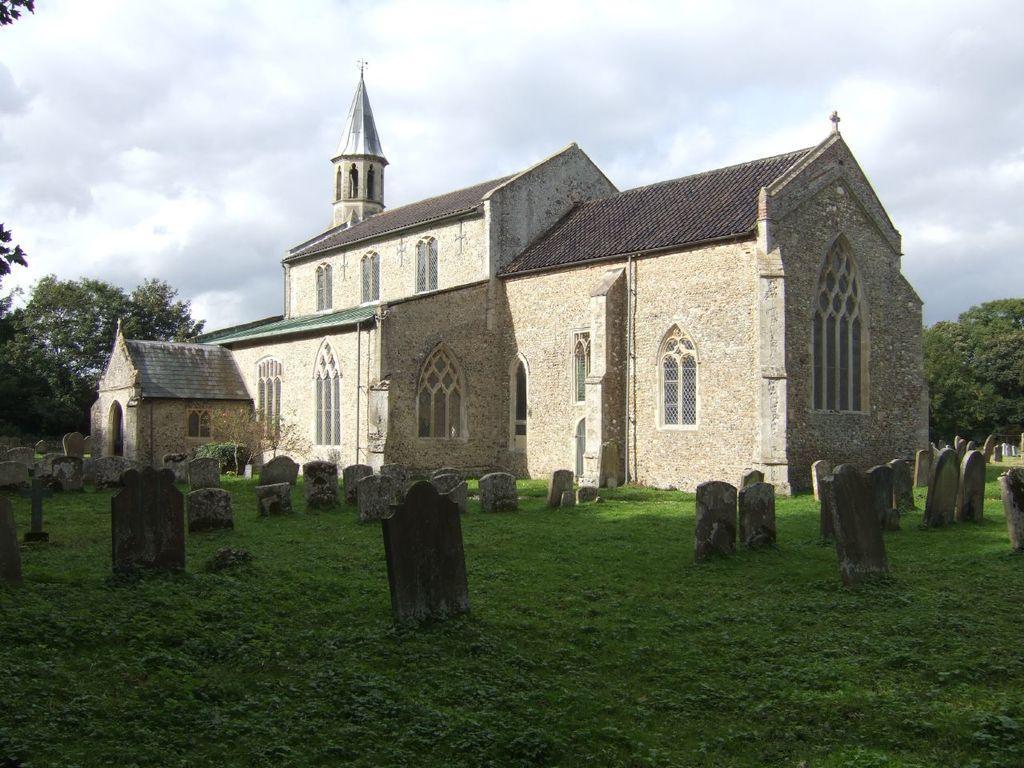How would you summarize this image in a sentence or two? In this image I can see gravesites, a building and the sky. In the background I can see trees and the sky. 